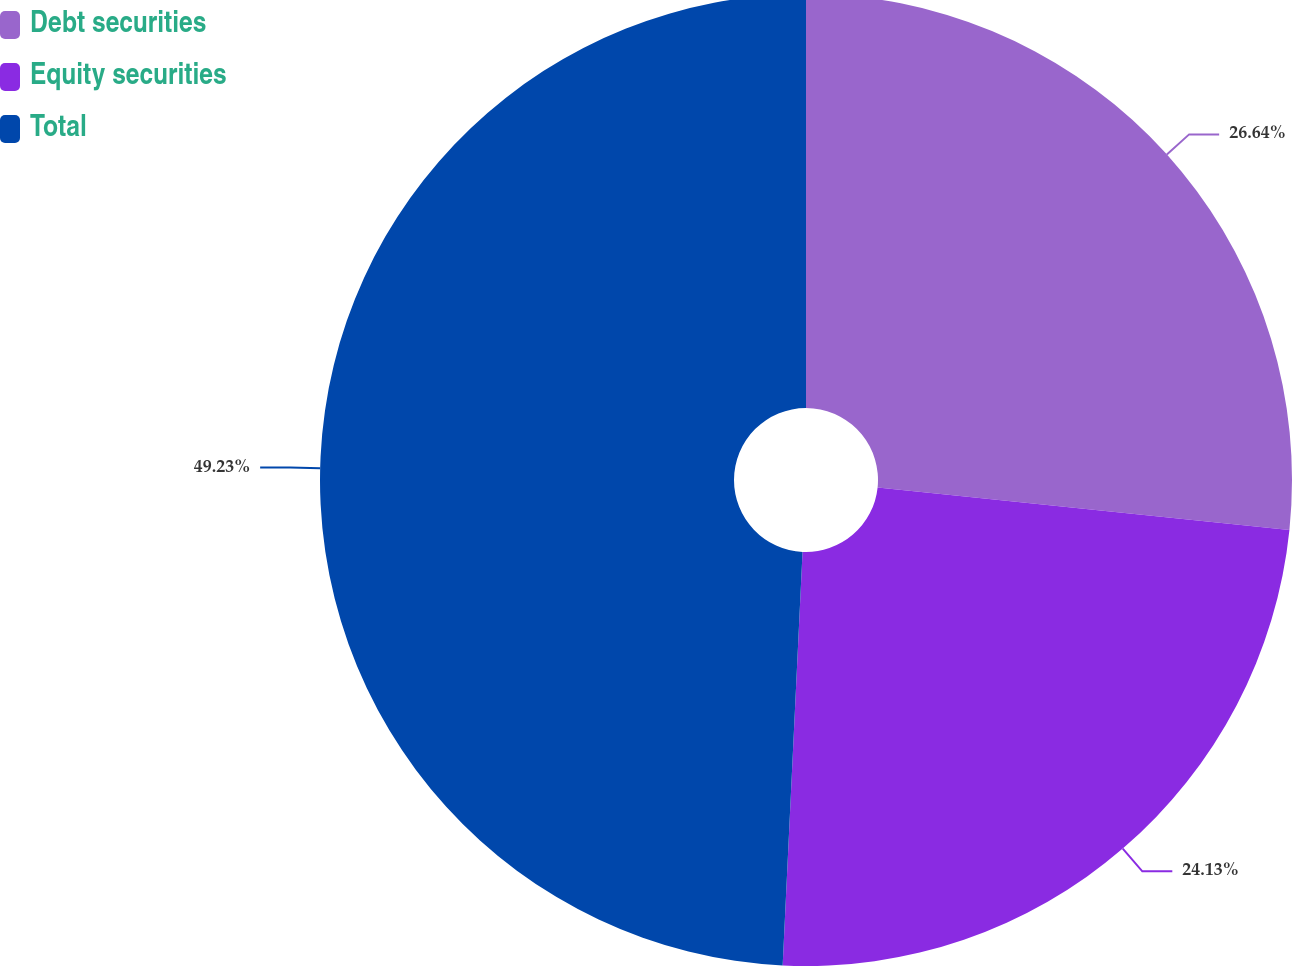Convert chart. <chart><loc_0><loc_0><loc_500><loc_500><pie_chart><fcel>Debt securities<fcel>Equity securities<fcel>Total<nl><fcel>26.64%<fcel>24.13%<fcel>49.24%<nl></chart> 